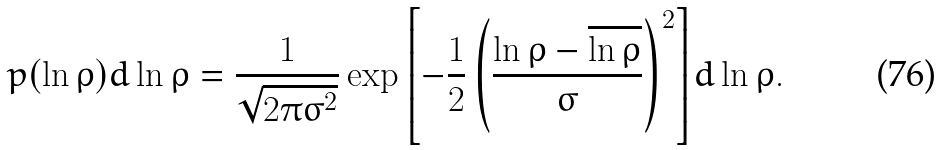<formula> <loc_0><loc_0><loc_500><loc_500>p ( \ln \rho ) d \ln \rho = \frac { 1 } { \sqrt { 2 \pi \sigma ^ { 2 } } } \exp { \left [ - \frac { 1 } { 2 } \left ( \frac { \ln \rho - \overline { \ln \rho } } { \sigma } \right ) ^ { 2 } \right ] } d \ln \rho .</formula> 